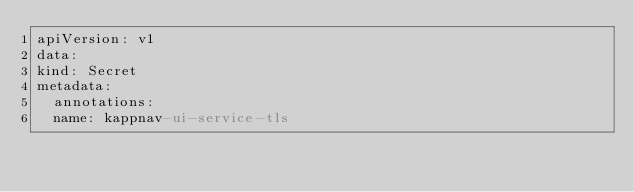<code> <loc_0><loc_0><loc_500><loc_500><_YAML_>apiVersion: v1
data:
kind: Secret
metadata:
  annotations:
  name: kappnav-ui-service-tls</code> 